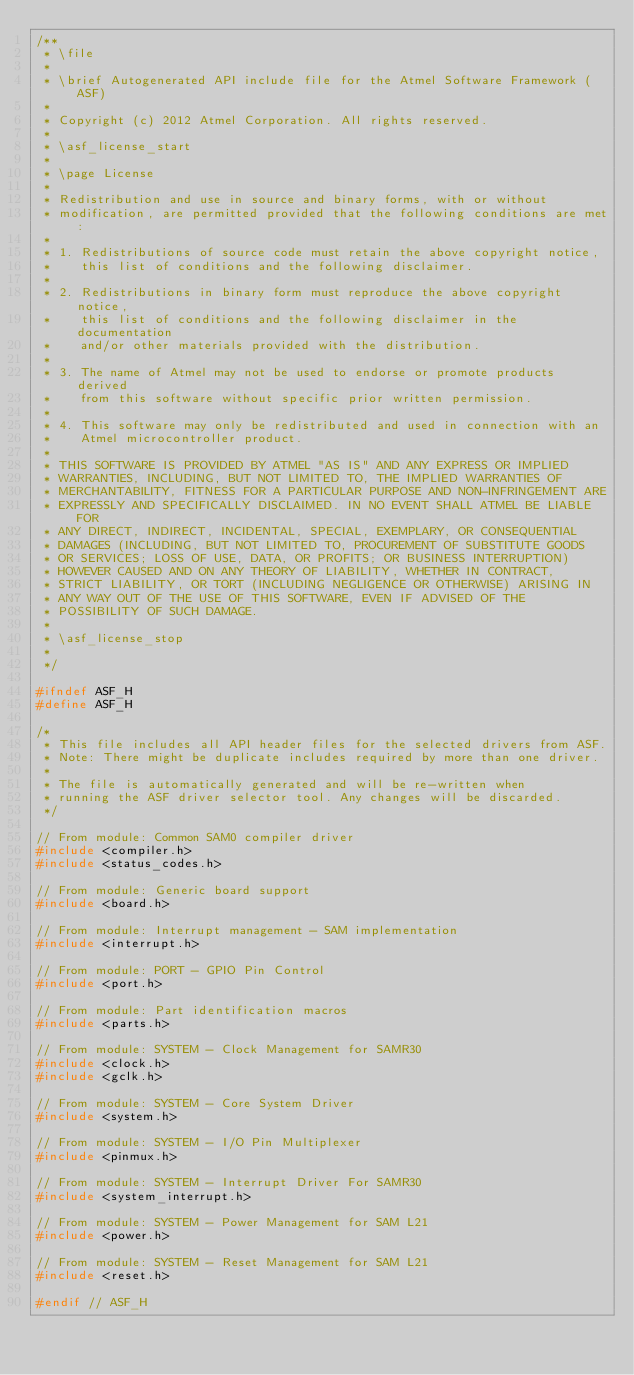Convert code to text. <code><loc_0><loc_0><loc_500><loc_500><_C_>/**
 * \file
 *
 * \brief Autogenerated API include file for the Atmel Software Framework (ASF)
 *
 * Copyright (c) 2012 Atmel Corporation. All rights reserved.
 *
 * \asf_license_start
 *
 * \page License
 *
 * Redistribution and use in source and binary forms, with or without
 * modification, are permitted provided that the following conditions are met:
 *
 * 1. Redistributions of source code must retain the above copyright notice,
 *    this list of conditions and the following disclaimer.
 *
 * 2. Redistributions in binary form must reproduce the above copyright notice,
 *    this list of conditions and the following disclaimer in the documentation
 *    and/or other materials provided with the distribution.
 *
 * 3. The name of Atmel may not be used to endorse or promote products derived
 *    from this software without specific prior written permission.
 *
 * 4. This software may only be redistributed and used in connection with an
 *    Atmel microcontroller product.
 *
 * THIS SOFTWARE IS PROVIDED BY ATMEL "AS IS" AND ANY EXPRESS OR IMPLIED
 * WARRANTIES, INCLUDING, BUT NOT LIMITED TO, THE IMPLIED WARRANTIES OF
 * MERCHANTABILITY, FITNESS FOR A PARTICULAR PURPOSE AND NON-INFRINGEMENT ARE
 * EXPRESSLY AND SPECIFICALLY DISCLAIMED. IN NO EVENT SHALL ATMEL BE LIABLE FOR
 * ANY DIRECT, INDIRECT, INCIDENTAL, SPECIAL, EXEMPLARY, OR CONSEQUENTIAL
 * DAMAGES (INCLUDING, BUT NOT LIMITED TO, PROCUREMENT OF SUBSTITUTE GOODS
 * OR SERVICES; LOSS OF USE, DATA, OR PROFITS; OR BUSINESS INTERRUPTION)
 * HOWEVER CAUSED AND ON ANY THEORY OF LIABILITY, WHETHER IN CONTRACT,
 * STRICT LIABILITY, OR TORT (INCLUDING NEGLIGENCE OR OTHERWISE) ARISING IN
 * ANY WAY OUT OF THE USE OF THIS SOFTWARE, EVEN IF ADVISED OF THE
 * POSSIBILITY OF SUCH DAMAGE.
 *
 * \asf_license_stop
 *
 */

#ifndef ASF_H
#define ASF_H

/*
 * This file includes all API header files for the selected drivers from ASF.
 * Note: There might be duplicate includes required by more than one driver.
 *
 * The file is automatically generated and will be re-written when
 * running the ASF driver selector tool. Any changes will be discarded.
 */

// From module: Common SAM0 compiler driver
#include <compiler.h>
#include <status_codes.h>

// From module: Generic board support
#include <board.h>

// From module: Interrupt management - SAM implementation
#include <interrupt.h>

// From module: PORT - GPIO Pin Control
#include <port.h>

// From module: Part identification macros
#include <parts.h>

// From module: SYSTEM - Clock Management for SAMR30
#include <clock.h>
#include <gclk.h>

// From module: SYSTEM - Core System Driver
#include <system.h>

// From module: SYSTEM - I/O Pin Multiplexer
#include <pinmux.h>

// From module: SYSTEM - Interrupt Driver For SAMR30
#include <system_interrupt.h>

// From module: SYSTEM - Power Management for SAM L21
#include <power.h>

// From module: SYSTEM - Reset Management for SAM L21
#include <reset.h>

#endif // ASF_H
</code> 